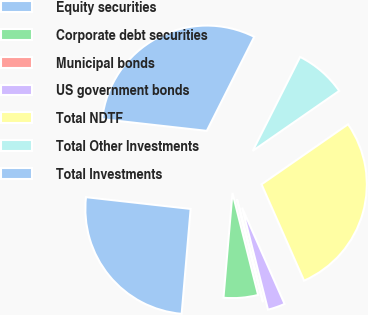Convert chart. <chart><loc_0><loc_0><loc_500><loc_500><pie_chart><fcel>Equity securities<fcel>Corporate debt securities<fcel>Municipal bonds<fcel>US government bonds<fcel>Total NDTF<fcel>Total Other Investments<fcel>Total Investments<nl><fcel>25.42%<fcel>5.28%<fcel>0.04%<fcel>2.66%<fcel>28.04%<fcel>7.91%<fcel>30.66%<nl></chart> 